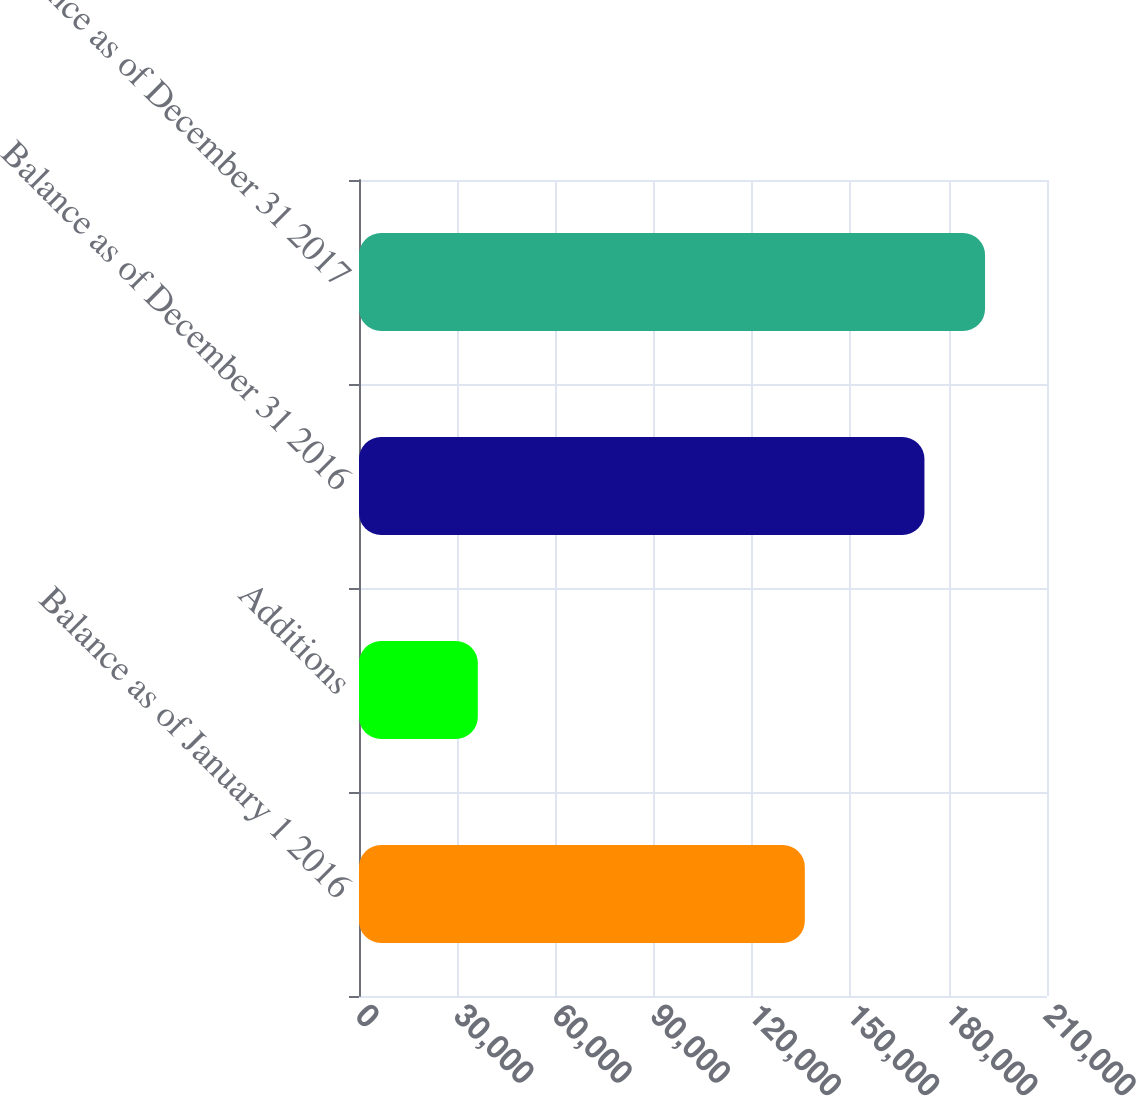<chart> <loc_0><loc_0><loc_500><loc_500><bar_chart><fcel>Balance as of January 1 2016<fcel>Additions<fcel>Balance as of December 31 2016<fcel>Balance as of December 31 2017<nl><fcel>136079<fcel>36267<fcel>172593<fcel>191091<nl></chart> 